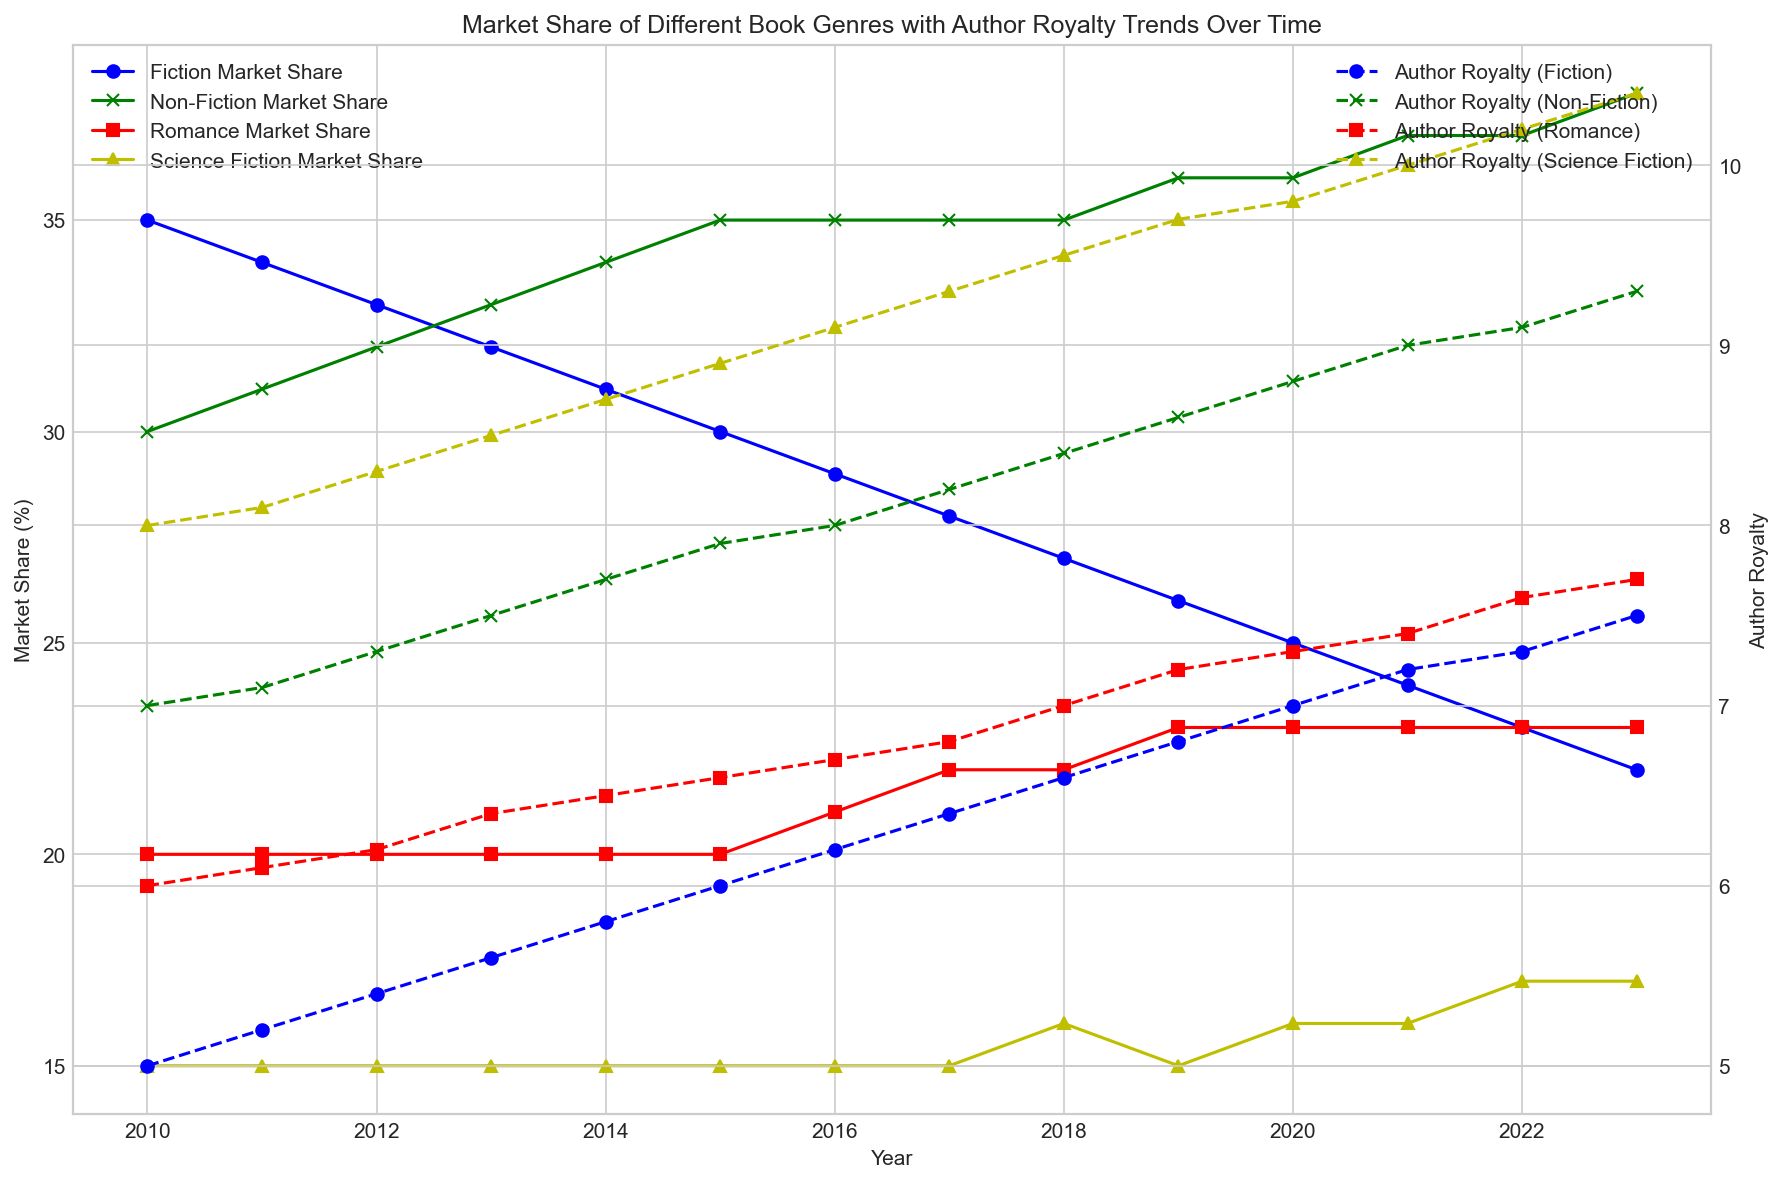What is the overall trend in Fiction Market Share from 2010 to 2023? By observing the blue line representing the Fiction Market Share, it is clear that it has been gradually decreasing over the years from 35% in 2010 to 22% in 2023.
Answer: Decreasing Which genre had the highest Market Share in 2023, and what was the value? Looking at the figure, the green line for the Non-Fiction Market Share reached the highest value of 38% in 2023.
Answer: Non-Fiction, 38% How did the Author Royalty (Romance) change from 2014 to 2023? The red dashed line for Author Royalty (Romance) shows an increase from 6.5 in 2014 to 7.7 in 2023.
Answer: Increased Which year showed equal Market Share for Fiction and Non-Fiction genres? The lines for Fiction and Non-Fiction Market Share intersect in 2015, showing equal Market Share of 35%.
Answer: 2015 What was the difference between the highest and lowest Author Royalty (Science Fiction) values from 2010 to 2023? The orange dashed line for Author Royalty (Science Fiction) starts with a value of 8 in 2010 and ends with a value of 10.4 in 2023, making the difference (10.4 - 8 = 2.4).
Answer: 2.4 In what year did Romance Market Share exceed its previous constant value, and by what amount? The red line for Romance Market Share rises above the constant value of 20% for the first time in 2016, reaching 21% (21 - 20 = 1).
Answer: 2016, 1% Compare the Author Royalty trends for Fiction and Non-Fiction from 2010 to 2023. Which one increased more? Author Royalty for Fiction increased from 5 to 7.5 (a total increase of 2.5), while Non-Fiction increased from 7 to 9.3 (a total increase of 2.3). Therefore, Fiction showed a higher total increase.
Answer: Fiction What is the total increase in Market Share for Science Fiction from 2010 to 2023? The yellow line for Science Fiction Market Share starts at 15% in 2010 and ends at 17% in 2023, making the total increase (17 - 15 = 2).
Answer: 2 Which genre showed the least Author Royalty in 2023, and what was the value? The figure shows that the blue dashed line for Author Royalty (Fiction) is the lowest in 2023 with a value of 7.5.
Answer: Fiction, 7.5 How do the trends in Market Share for Romance and Science Fiction compare from 2018 to 2023? The red and yellow solid lines show that Romance Market Share remains constant at 23% from 2018 to 2023, while Science Fiction Market Share shows a slight increase from 16% in 2018 to 17% in 2023.
Answer: Romance: constant, Science Fiction: increase 